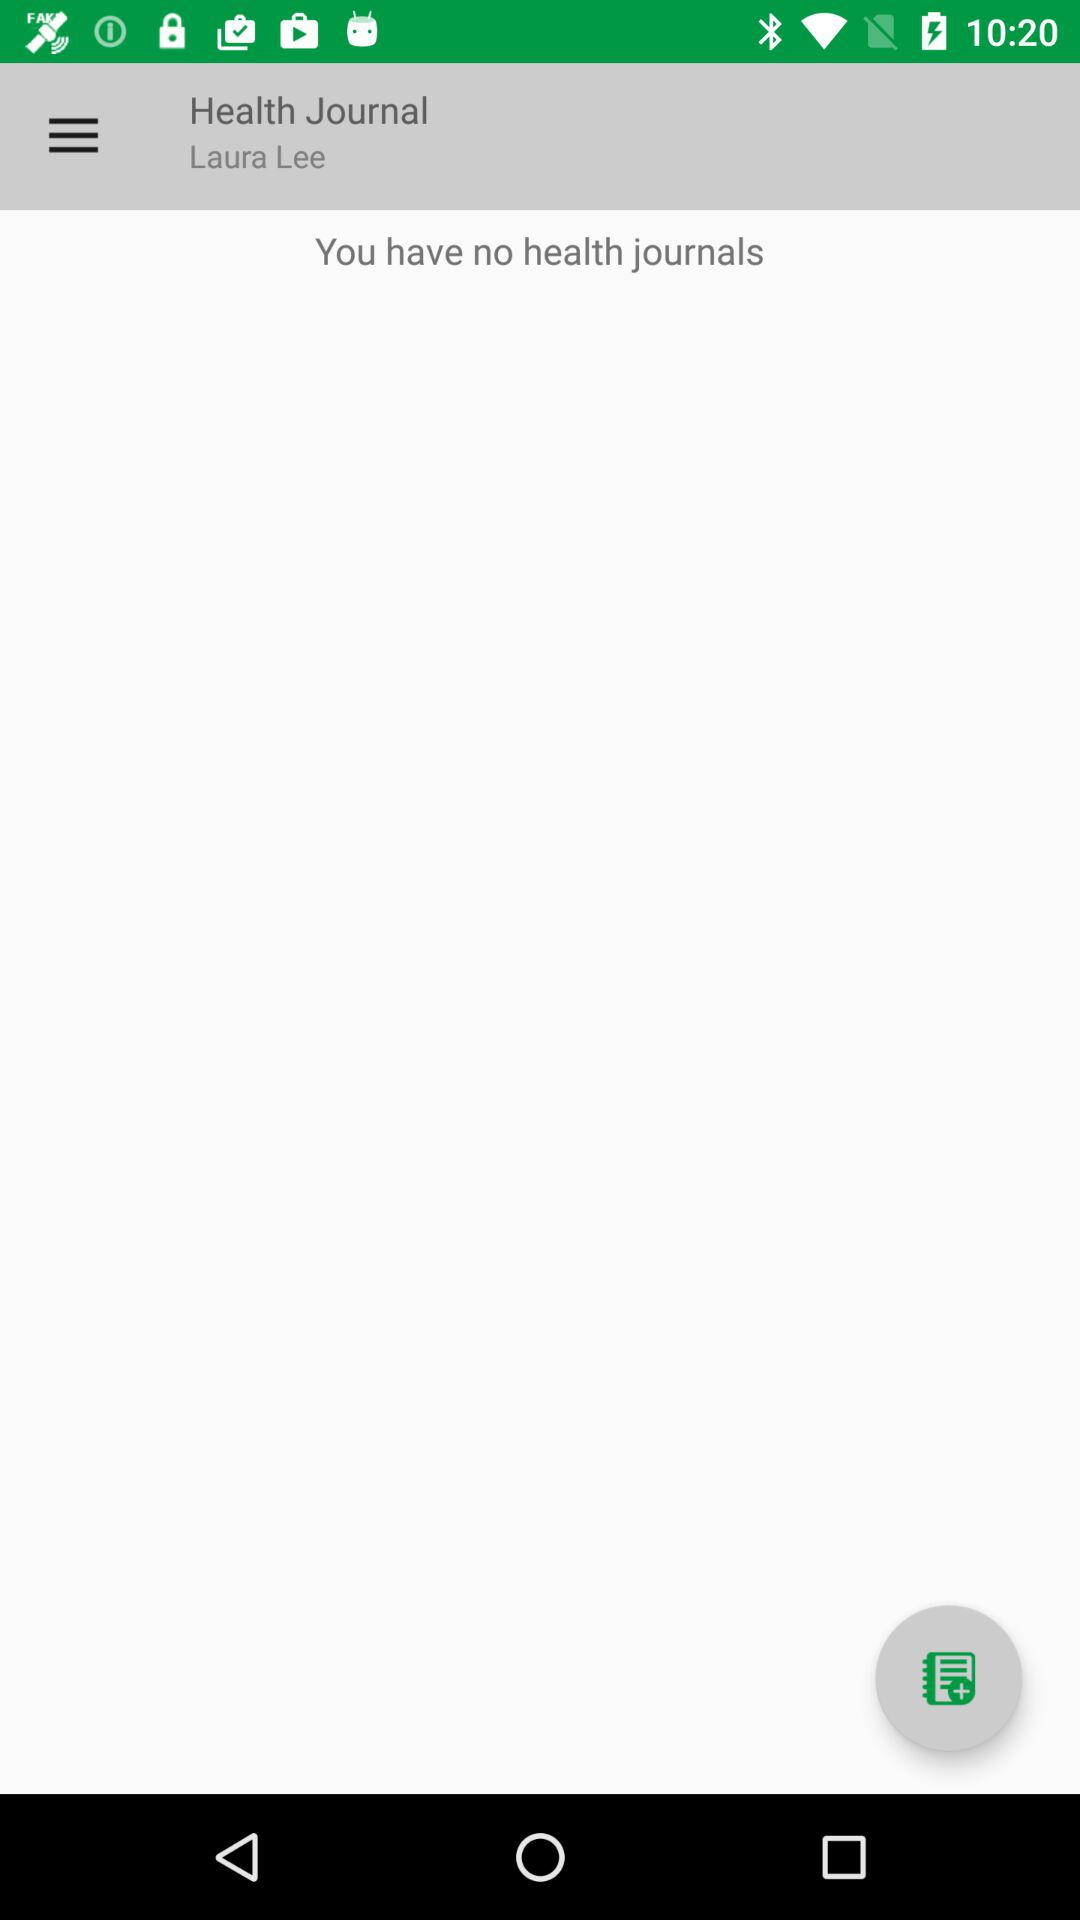What is the application name? The application name is "Health Journal". 